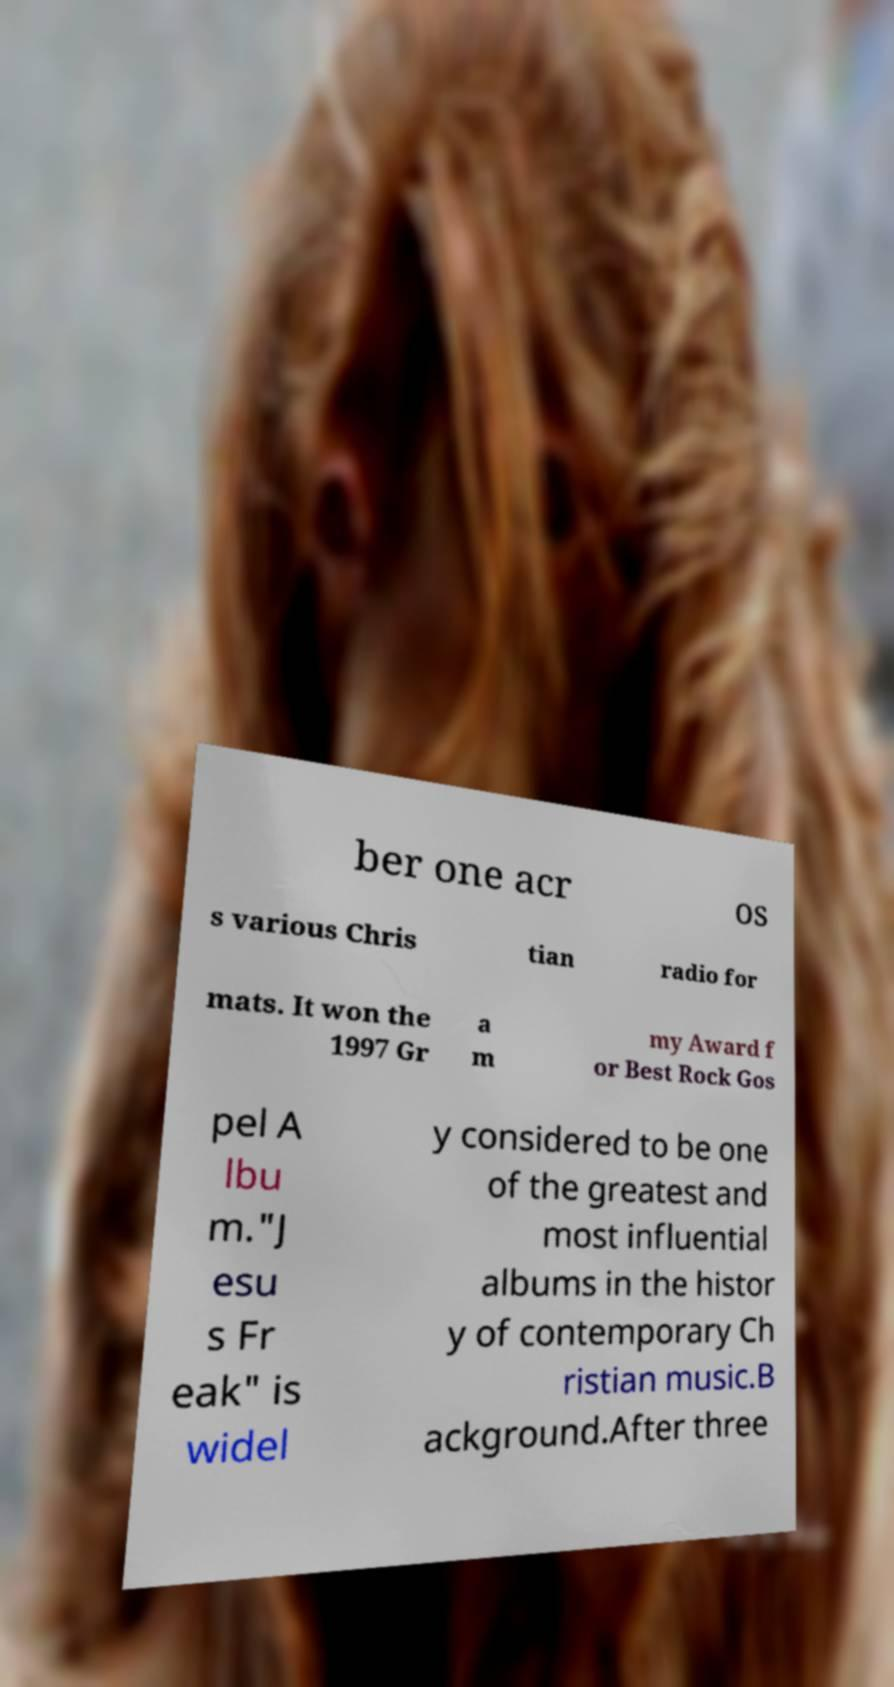Can you accurately transcribe the text from the provided image for me? ber one acr os s various Chris tian radio for mats. It won the 1997 Gr a m my Award f or Best Rock Gos pel A lbu m."J esu s Fr eak" is widel y considered to be one of the greatest and most influential albums in the histor y of contemporary Ch ristian music.B ackground.After three 